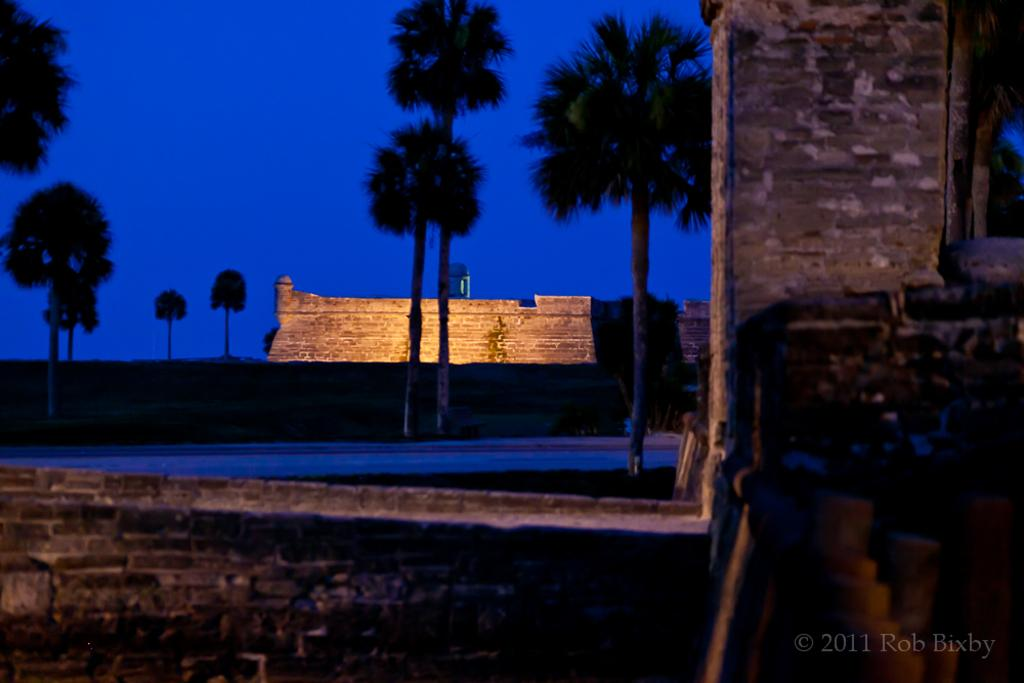What is the main structure in the image? There is a monument in the image. What type of natural elements can be seen in the image? There are trees in the image. What architectural feature is present in the image? There is a wall in the image. What is visible in the background of the image? The sky is visible in the image. Can you tell me how many parents are crying in the image? There are no parents or crying depicted in the image; it features a monument, trees, a wall, and the sky. What type of insurance policy is being discussed in the image? There is no discussion of insurance policies in the image; it focuses on a monument, trees, a wall, and the sky. 